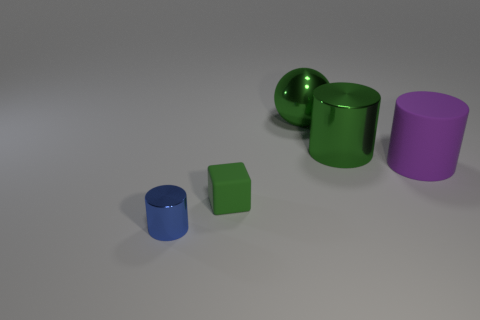Are there any metal cylinders of the same size as the green cube?
Give a very brief answer. Yes. There is a blue object that is the same size as the green cube; what shape is it?
Offer a terse response. Cylinder. Are there any other purple things that have the same shape as the big purple rubber object?
Your answer should be compact. No. Do the big green sphere and the tiny object on the left side of the green matte thing have the same material?
Offer a terse response. Yes. Is there another tiny rubber cube of the same color as the tiny rubber block?
Make the answer very short. No. What number of other things are there of the same material as the big purple thing
Ensure brevity in your answer.  1. Is the color of the matte cube the same as the cylinder in front of the large matte cylinder?
Provide a succinct answer. No. Are there more metal cylinders in front of the small green rubber block than large green cylinders?
Provide a succinct answer. No. There is a thing that is behind the big shiny cylinder in front of the big green sphere; what number of small rubber blocks are behind it?
Offer a terse response. 0. Do the shiny object in front of the rubber cylinder and the small rubber thing have the same shape?
Make the answer very short. No. 